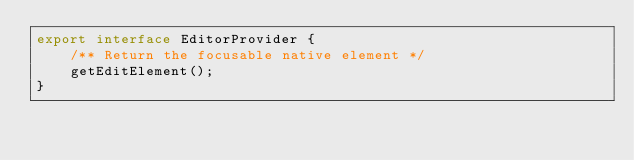<code> <loc_0><loc_0><loc_500><loc_500><_TypeScript_>export interface EditorProvider {
    /** Return the focusable native element */
    getEditElement();
}
</code> 